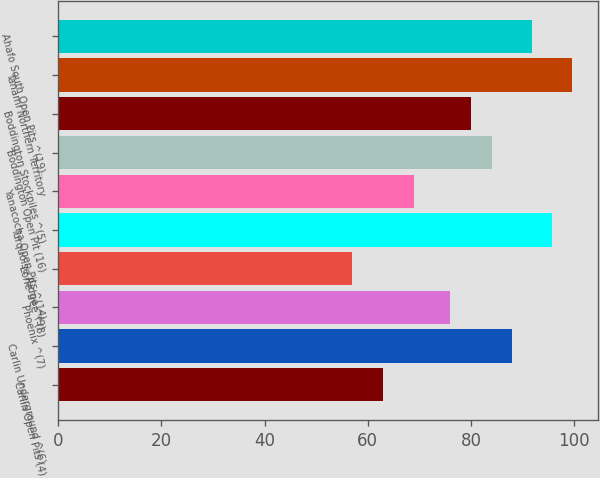Convert chart. <chart><loc_0><loc_0><loc_500><loc_500><bar_chart><fcel>Carlin Open Pits (4)<fcel>Carlin Underground ^(6)<fcel>Phoenix ^(7)<fcel>Lone Tree ^(8)<fcel>Turquoise Ridge ^(9)<fcel>Yanacocha Open Pits ^(14)<fcel>Boddington Open Pit (16)<fcel>Boddington Stockpiles ^(5)<fcel>Tanami Northern Territory<fcel>Ahafo South Open Pits ^(19)<nl><fcel>63<fcel>87.9<fcel>76<fcel>57<fcel>95.7<fcel>69<fcel>84<fcel>79.9<fcel>99.6<fcel>91.8<nl></chart> 